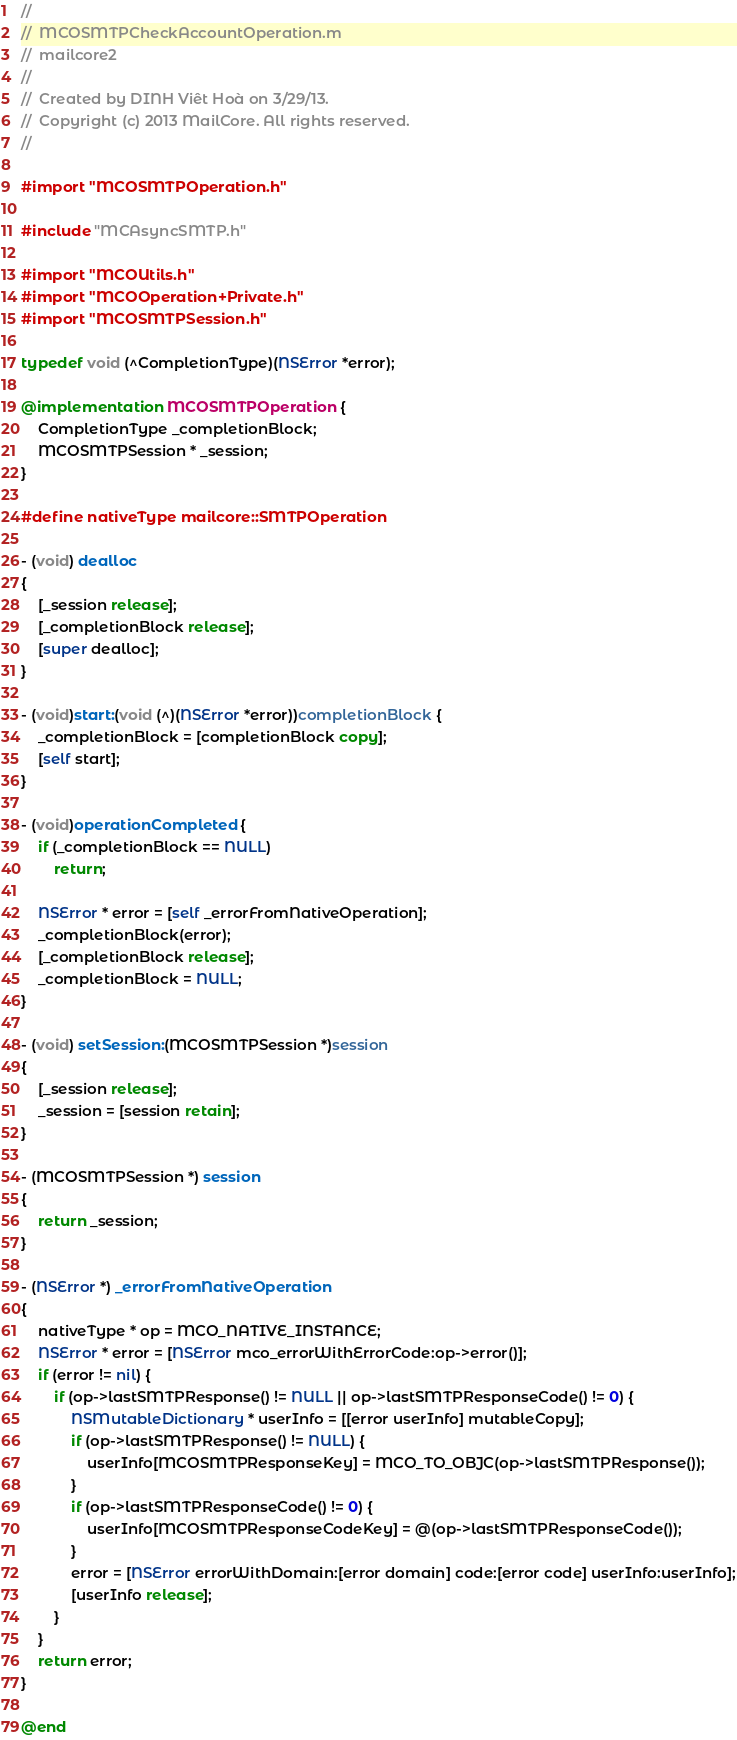<code> <loc_0><loc_0><loc_500><loc_500><_ObjectiveC_>//
//  MCOSMTPCheckAccountOperation.m
//  mailcore2
//
//  Created by DINH Viêt Hoà on 3/29/13.
//  Copyright (c) 2013 MailCore. All rights reserved.
//

#import "MCOSMTPOperation.h"

#include "MCAsyncSMTP.h"

#import "MCOUtils.h"
#import "MCOOperation+Private.h"
#import "MCOSMTPSession.h"

typedef void (^CompletionType)(NSError *error);

@implementation MCOSMTPOperation {
    CompletionType _completionBlock;
    MCOSMTPSession * _session;
}

#define nativeType mailcore::SMTPOperation

- (void) dealloc
{
    [_session release];
    [_completionBlock release];
    [super dealloc];
}

- (void)start:(void (^)(NSError *error))completionBlock {
    _completionBlock = [completionBlock copy];
    [self start];
}

- (void)operationCompleted {
    if (_completionBlock == NULL)
        return;
    
    NSError * error = [self _errorFromNativeOperation];
    _completionBlock(error);
    [_completionBlock release];
    _completionBlock = NULL;
}

- (void) setSession:(MCOSMTPSession *)session
{
    [_session release];
    _session = [session retain];
}

- (MCOSMTPSession *) session
{
    return _session;
}

- (NSError *) _errorFromNativeOperation
{
    nativeType * op = MCO_NATIVE_INSTANCE;
    NSError * error = [NSError mco_errorWithErrorCode:op->error()];
    if (error != nil) {
        if (op->lastSMTPResponse() != NULL || op->lastSMTPResponseCode() != 0) {
            NSMutableDictionary * userInfo = [[error userInfo] mutableCopy];
            if (op->lastSMTPResponse() != NULL) {
                userInfo[MCOSMTPResponseKey] = MCO_TO_OBJC(op->lastSMTPResponse());
            }
            if (op->lastSMTPResponseCode() != 0) {
                userInfo[MCOSMTPResponseCodeKey] = @(op->lastSMTPResponseCode());
            }
            error = [NSError errorWithDomain:[error domain] code:[error code] userInfo:userInfo];
            [userInfo release];
        }
    }
    return error;
}

@end
</code> 